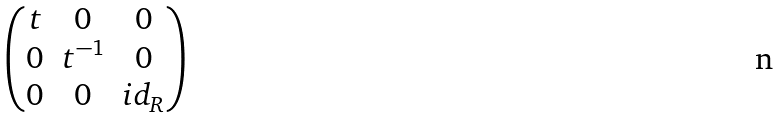<formula> <loc_0><loc_0><loc_500><loc_500>\begin{pmatrix} t & 0 & 0 \\ 0 & t ^ { - 1 } & 0 \\ 0 & 0 & i d _ { R } \end{pmatrix}</formula> 